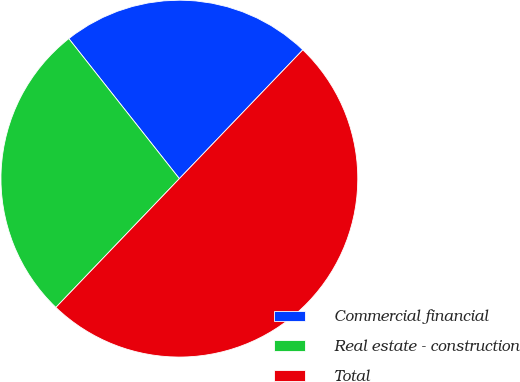<chart> <loc_0><loc_0><loc_500><loc_500><pie_chart><fcel>Commercial financial<fcel>Real estate - construction<fcel>Total<nl><fcel>22.8%<fcel>27.2%<fcel>50.0%<nl></chart> 